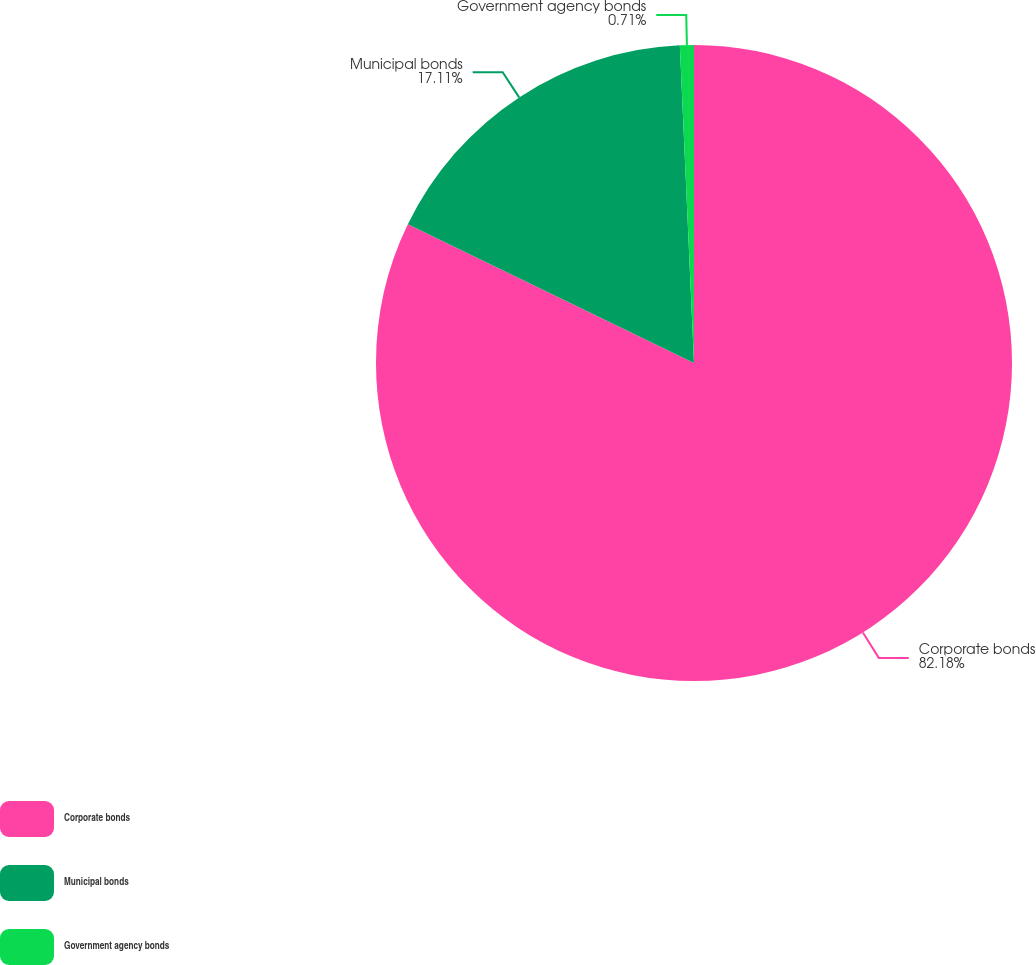Convert chart to OTSL. <chart><loc_0><loc_0><loc_500><loc_500><pie_chart><fcel>Corporate bonds<fcel>Municipal bonds<fcel>Government agency bonds<nl><fcel>82.18%<fcel>17.11%<fcel>0.71%<nl></chart> 